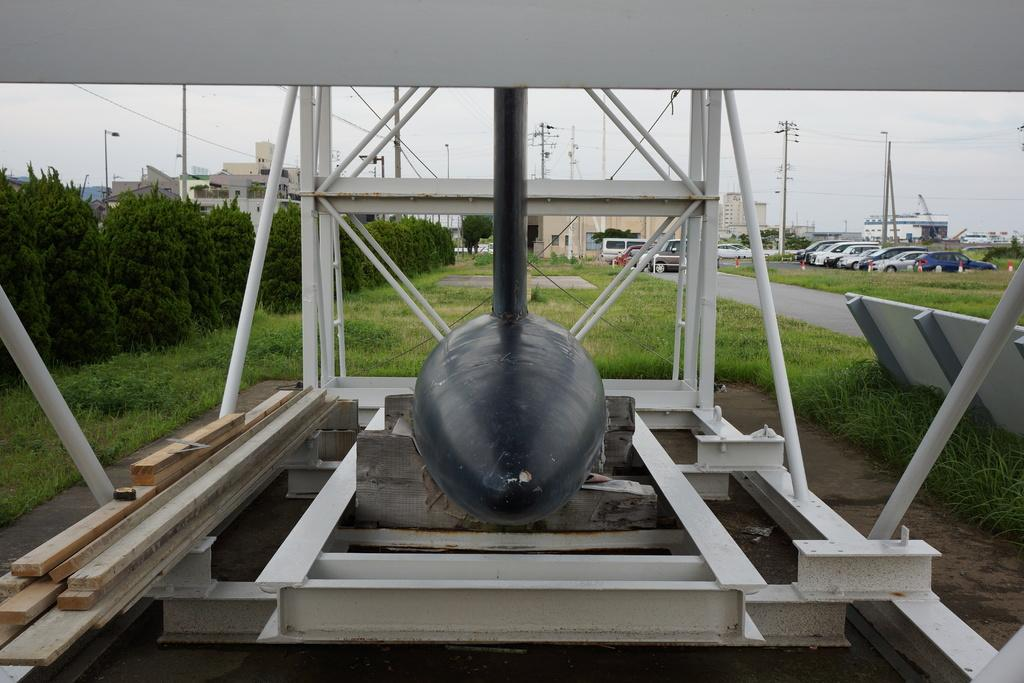What is the main subject in the center of the image? There is a tower in the center of the image. What can be seen in the background of the image? There are buildings, poles, trees, cars, wires, and the sky visible in the background of the image. What is at the bottom of the image? There is grass at the bottom of the image. What type of market can be seen in the image? There is no market present in the image. How many breaths can be counted in the image? Breaths cannot be seen or counted in the image, as it is a still photograph. 